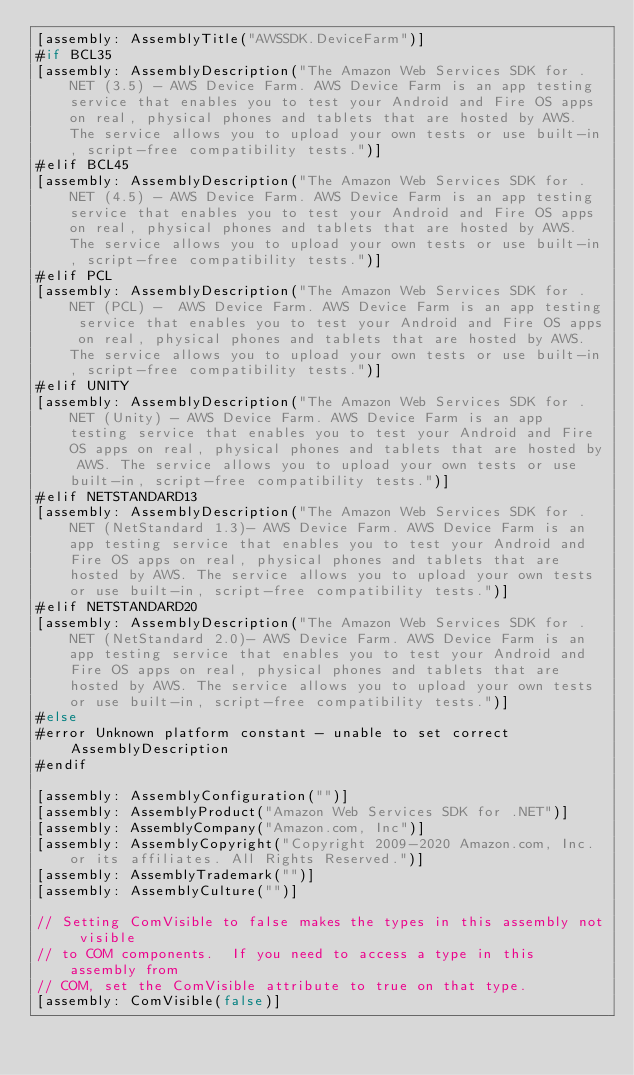<code> <loc_0><loc_0><loc_500><loc_500><_C#_>[assembly: AssemblyTitle("AWSSDK.DeviceFarm")]
#if BCL35
[assembly: AssemblyDescription("The Amazon Web Services SDK for .NET (3.5) - AWS Device Farm. AWS Device Farm is an app testing service that enables you to test your Android and Fire OS apps on real, physical phones and tablets that are hosted by AWS. The service allows you to upload your own tests or use built-in, script-free compatibility tests.")]
#elif BCL45
[assembly: AssemblyDescription("The Amazon Web Services SDK for .NET (4.5) - AWS Device Farm. AWS Device Farm is an app testing service that enables you to test your Android and Fire OS apps on real, physical phones and tablets that are hosted by AWS. The service allows you to upload your own tests or use built-in, script-free compatibility tests.")]
#elif PCL
[assembly: AssemblyDescription("The Amazon Web Services SDK for .NET (PCL) -  AWS Device Farm. AWS Device Farm is an app testing service that enables you to test your Android and Fire OS apps on real, physical phones and tablets that are hosted by AWS. The service allows you to upload your own tests or use built-in, script-free compatibility tests.")]
#elif UNITY
[assembly: AssemblyDescription("The Amazon Web Services SDK for .NET (Unity) - AWS Device Farm. AWS Device Farm is an app testing service that enables you to test your Android and Fire OS apps on real, physical phones and tablets that are hosted by AWS. The service allows you to upload your own tests or use built-in, script-free compatibility tests.")]
#elif NETSTANDARD13
[assembly: AssemblyDescription("The Amazon Web Services SDK for .NET (NetStandard 1.3)- AWS Device Farm. AWS Device Farm is an app testing service that enables you to test your Android and Fire OS apps on real, physical phones and tablets that are hosted by AWS. The service allows you to upload your own tests or use built-in, script-free compatibility tests.")]
#elif NETSTANDARD20
[assembly: AssemblyDescription("The Amazon Web Services SDK for .NET (NetStandard 2.0)- AWS Device Farm. AWS Device Farm is an app testing service that enables you to test your Android and Fire OS apps on real, physical phones and tablets that are hosted by AWS. The service allows you to upload your own tests or use built-in, script-free compatibility tests.")]
#else
#error Unknown platform constant - unable to set correct AssemblyDescription
#endif

[assembly: AssemblyConfiguration("")]
[assembly: AssemblyProduct("Amazon Web Services SDK for .NET")]
[assembly: AssemblyCompany("Amazon.com, Inc")]
[assembly: AssemblyCopyright("Copyright 2009-2020 Amazon.com, Inc. or its affiliates. All Rights Reserved.")]
[assembly: AssemblyTrademark("")]
[assembly: AssemblyCulture("")]

// Setting ComVisible to false makes the types in this assembly not visible 
// to COM components.  If you need to access a type in this assembly from 
// COM, set the ComVisible attribute to true on that type.
[assembly: ComVisible(false)]
</code> 